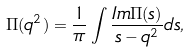Convert formula to latex. <formula><loc_0><loc_0><loc_500><loc_500>\Pi ( q ^ { 2 } ) = \frac { 1 } { \pi } \int \frac { I m \Pi ( s ) } { s - q ^ { 2 } } d s ,</formula> 